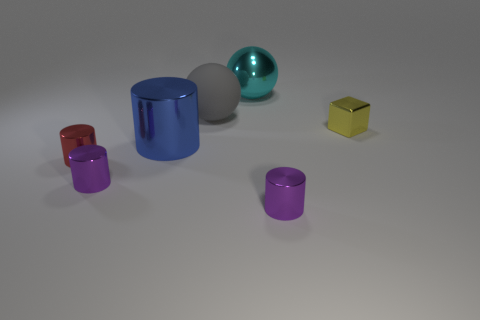There is a gray matte sphere; is its size the same as the purple cylinder that is to the right of the blue metallic object?
Your response must be concise. No. How many other things are there of the same material as the block?
Ensure brevity in your answer.  5. Is there anything else that has the same shape as the yellow thing?
Offer a terse response. No. There is a small metal object that is on the right side of the small metallic cylinder in front of the small purple cylinder to the left of the matte sphere; what color is it?
Provide a succinct answer. Yellow. There is a thing that is behind the large blue shiny thing and to the right of the big cyan metal object; what is its shape?
Offer a very short reply. Cube. Are there any other things that have the same size as the red metallic cylinder?
Offer a very short reply. Yes. What is the color of the shiny object that is to the left of the small purple metallic cylinder that is on the left side of the blue cylinder?
Your answer should be compact. Red. The tiny object that is on the right side of the small purple metallic object right of the large thing that is in front of the yellow object is what shape?
Keep it short and to the point. Cube. There is a object that is to the right of the big gray matte sphere and behind the small cube; what size is it?
Keep it short and to the point. Large. What material is the yellow block?
Your answer should be compact. Metal. 